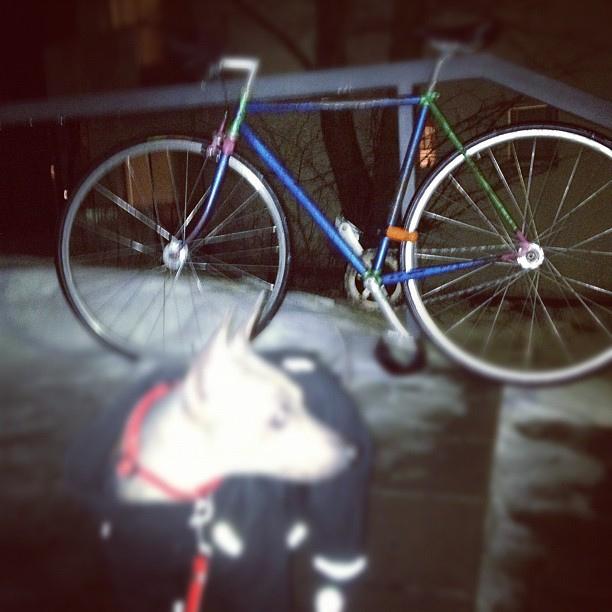How many spokes does this bicycle have?
Short answer required. 2. What kind of animal is in this image?
Concise answer only. Dog. How many wheels does this vehicle have?
Be succinct. 2. 